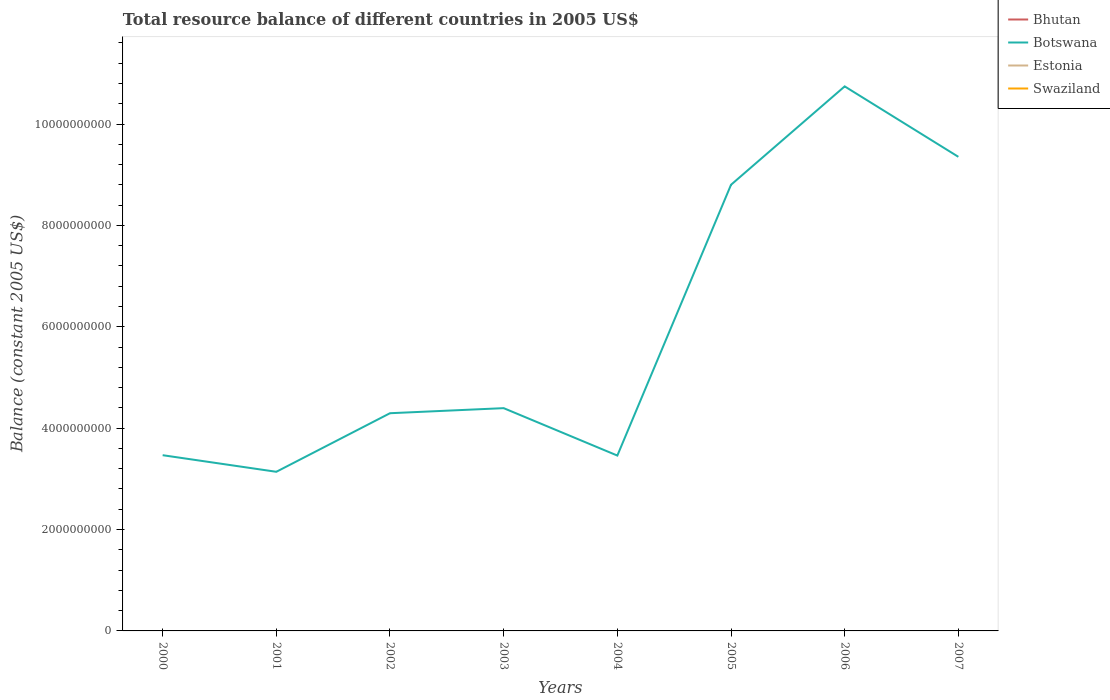Does the line corresponding to Swaziland intersect with the line corresponding to Bhutan?
Your answer should be compact. No. Is the number of lines equal to the number of legend labels?
Offer a terse response. No. What is the total total resource balance in Botswana in the graph?
Make the answer very short. -5.51e+08. What is the difference between the highest and the second highest total resource balance in Botswana?
Your response must be concise. 7.60e+09. What is the difference between the highest and the lowest total resource balance in Estonia?
Ensure brevity in your answer.  0. How many years are there in the graph?
Keep it short and to the point. 8. Are the values on the major ticks of Y-axis written in scientific E-notation?
Your response must be concise. No. Does the graph contain any zero values?
Give a very brief answer. Yes. Does the graph contain grids?
Offer a terse response. No. Where does the legend appear in the graph?
Ensure brevity in your answer.  Top right. How are the legend labels stacked?
Provide a succinct answer. Vertical. What is the title of the graph?
Make the answer very short. Total resource balance of different countries in 2005 US$. Does "Hong Kong" appear as one of the legend labels in the graph?
Keep it short and to the point. No. What is the label or title of the X-axis?
Keep it short and to the point. Years. What is the label or title of the Y-axis?
Offer a very short reply. Balance (constant 2005 US$). What is the Balance (constant 2005 US$) in Bhutan in 2000?
Your answer should be very brief. 0. What is the Balance (constant 2005 US$) in Botswana in 2000?
Your answer should be very brief. 3.47e+09. What is the Balance (constant 2005 US$) in Bhutan in 2001?
Offer a very short reply. 0. What is the Balance (constant 2005 US$) of Botswana in 2001?
Your answer should be compact. 3.14e+09. What is the Balance (constant 2005 US$) in Swaziland in 2001?
Give a very brief answer. 0. What is the Balance (constant 2005 US$) of Botswana in 2002?
Ensure brevity in your answer.  4.29e+09. What is the Balance (constant 2005 US$) in Estonia in 2002?
Your response must be concise. 0. What is the Balance (constant 2005 US$) of Swaziland in 2002?
Offer a very short reply. 0. What is the Balance (constant 2005 US$) in Botswana in 2003?
Give a very brief answer. 4.39e+09. What is the Balance (constant 2005 US$) of Estonia in 2003?
Your answer should be compact. 0. What is the Balance (constant 2005 US$) in Swaziland in 2003?
Provide a short and direct response. 0. What is the Balance (constant 2005 US$) in Bhutan in 2004?
Give a very brief answer. 0. What is the Balance (constant 2005 US$) of Botswana in 2004?
Offer a very short reply. 3.46e+09. What is the Balance (constant 2005 US$) in Swaziland in 2004?
Keep it short and to the point. 0. What is the Balance (constant 2005 US$) of Bhutan in 2005?
Your answer should be compact. 0. What is the Balance (constant 2005 US$) of Botswana in 2005?
Offer a terse response. 8.80e+09. What is the Balance (constant 2005 US$) in Estonia in 2005?
Provide a succinct answer. 0. What is the Balance (constant 2005 US$) of Swaziland in 2005?
Offer a terse response. 0. What is the Balance (constant 2005 US$) of Bhutan in 2006?
Keep it short and to the point. 0. What is the Balance (constant 2005 US$) of Botswana in 2006?
Offer a very short reply. 1.07e+1. What is the Balance (constant 2005 US$) in Swaziland in 2006?
Provide a succinct answer. 0. What is the Balance (constant 2005 US$) in Bhutan in 2007?
Your answer should be very brief. 0. What is the Balance (constant 2005 US$) in Botswana in 2007?
Your answer should be compact. 9.35e+09. What is the Balance (constant 2005 US$) of Estonia in 2007?
Provide a succinct answer. 0. What is the Balance (constant 2005 US$) of Swaziland in 2007?
Provide a short and direct response. 0. Across all years, what is the maximum Balance (constant 2005 US$) in Botswana?
Make the answer very short. 1.07e+1. Across all years, what is the minimum Balance (constant 2005 US$) in Botswana?
Your answer should be very brief. 3.14e+09. What is the total Balance (constant 2005 US$) of Bhutan in the graph?
Offer a very short reply. 0. What is the total Balance (constant 2005 US$) in Botswana in the graph?
Your answer should be compact. 4.77e+1. What is the difference between the Balance (constant 2005 US$) of Botswana in 2000 and that in 2001?
Your answer should be compact. 3.27e+08. What is the difference between the Balance (constant 2005 US$) in Botswana in 2000 and that in 2002?
Ensure brevity in your answer.  -8.28e+08. What is the difference between the Balance (constant 2005 US$) in Botswana in 2000 and that in 2003?
Provide a succinct answer. -9.28e+08. What is the difference between the Balance (constant 2005 US$) of Botswana in 2000 and that in 2004?
Ensure brevity in your answer.  7.10e+06. What is the difference between the Balance (constant 2005 US$) in Botswana in 2000 and that in 2005?
Your response must be concise. -5.33e+09. What is the difference between the Balance (constant 2005 US$) in Botswana in 2000 and that in 2006?
Offer a terse response. -7.28e+09. What is the difference between the Balance (constant 2005 US$) of Botswana in 2000 and that in 2007?
Your response must be concise. -5.89e+09. What is the difference between the Balance (constant 2005 US$) of Botswana in 2001 and that in 2002?
Make the answer very short. -1.16e+09. What is the difference between the Balance (constant 2005 US$) of Botswana in 2001 and that in 2003?
Give a very brief answer. -1.26e+09. What is the difference between the Balance (constant 2005 US$) in Botswana in 2001 and that in 2004?
Provide a succinct answer. -3.20e+08. What is the difference between the Balance (constant 2005 US$) of Botswana in 2001 and that in 2005?
Your response must be concise. -5.66e+09. What is the difference between the Balance (constant 2005 US$) in Botswana in 2001 and that in 2006?
Your answer should be very brief. -7.60e+09. What is the difference between the Balance (constant 2005 US$) of Botswana in 2001 and that in 2007?
Ensure brevity in your answer.  -6.21e+09. What is the difference between the Balance (constant 2005 US$) in Botswana in 2002 and that in 2003?
Ensure brevity in your answer.  -9.99e+07. What is the difference between the Balance (constant 2005 US$) in Botswana in 2002 and that in 2004?
Your response must be concise. 8.35e+08. What is the difference between the Balance (constant 2005 US$) in Botswana in 2002 and that in 2005?
Provide a short and direct response. -4.51e+09. What is the difference between the Balance (constant 2005 US$) of Botswana in 2002 and that in 2006?
Give a very brief answer. -6.45e+09. What is the difference between the Balance (constant 2005 US$) of Botswana in 2002 and that in 2007?
Your response must be concise. -5.06e+09. What is the difference between the Balance (constant 2005 US$) in Botswana in 2003 and that in 2004?
Keep it short and to the point. 9.35e+08. What is the difference between the Balance (constant 2005 US$) in Botswana in 2003 and that in 2005?
Give a very brief answer. -4.41e+09. What is the difference between the Balance (constant 2005 US$) in Botswana in 2003 and that in 2006?
Provide a short and direct response. -6.35e+09. What is the difference between the Balance (constant 2005 US$) in Botswana in 2003 and that in 2007?
Your answer should be very brief. -4.96e+09. What is the difference between the Balance (constant 2005 US$) of Botswana in 2004 and that in 2005?
Offer a terse response. -5.34e+09. What is the difference between the Balance (constant 2005 US$) in Botswana in 2004 and that in 2006?
Ensure brevity in your answer.  -7.28e+09. What is the difference between the Balance (constant 2005 US$) of Botswana in 2004 and that in 2007?
Provide a short and direct response. -5.89e+09. What is the difference between the Balance (constant 2005 US$) in Botswana in 2005 and that in 2006?
Provide a short and direct response. -1.94e+09. What is the difference between the Balance (constant 2005 US$) in Botswana in 2005 and that in 2007?
Offer a terse response. -5.51e+08. What is the difference between the Balance (constant 2005 US$) of Botswana in 2006 and that in 2007?
Make the answer very short. 1.39e+09. What is the average Balance (constant 2005 US$) in Bhutan per year?
Offer a terse response. 0. What is the average Balance (constant 2005 US$) in Botswana per year?
Your answer should be compact. 5.96e+09. What is the average Balance (constant 2005 US$) of Estonia per year?
Offer a terse response. 0. What is the average Balance (constant 2005 US$) in Swaziland per year?
Your answer should be compact. 0. What is the ratio of the Balance (constant 2005 US$) in Botswana in 2000 to that in 2001?
Offer a terse response. 1.1. What is the ratio of the Balance (constant 2005 US$) of Botswana in 2000 to that in 2002?
Your response must be concise. 0.81. What is the ratio of the Balance (constant 2005 US$) of Botswana in 2000 to that in 2003?
Your answer should be compact. 0.79. What is the ratio of the Balance (constant 2005 US$) in Botswana in 2000 to that in 2005?
Offer a very short reply. 0.39. What is the ratio of the Balance (constant 2005 US$) in Botswana in 2000 to that in 2006?
Your response must be concise. 0.32. What is the ratio of the Balance (constant 2005 US$) of Botswana in 2000 to that in 2007?
Your answer should be very brief. 0.37. What is the ratio of the Balance (constant 2005 US$) in Botswana in 2001 to that in 2002?
Your answer should be compact. 0.73. What is the ratio of the Balance (constant 2005 US$) in Botswana in 2001 to that in 2004?
Ensure brevity in your answer.  0.91. What is the ratio of the Balance (constant 2005 US$) of Botswana in 2001 to that in 2005?
Make the answer very short. 0.36. What is the ratio of the Balance (constant 2005 US$) in Botswana in 2001 to that in 2006?
Your answer should be compact. 0.29. What is the ratio of the Balance (constant 2005 US$) of Botswana in 2001 to that in 2007?
Your response must be concise. 0.34. What is the ratio of the Balance (constant 2005 US$) of Botswana in 2002 to that in 2003?
Offer a terse response. 0.98. What is the ratio of the Balance (constant 2005 US$) in Botswana in 2002 to that in 2004?
Offer a very short reply. 1.24. What is the ratio of the Balance (constant 2005 US$) in Botswana in 2002 to that in 2005?
Your answer should be very brief. 0.49. What is the ratio of the Balance (constant 2005 US$) in Botswana in 2002 to that in 2006?
Your response must be concise. 0.4. What is the ratio of the Balance (constant 2005 US$) of Botswana in 2002 to that in 2007?
Offer a terse response. 0.46. What is the ratio of the Balance (constant 2005 US$) of Botswana in 2003 to that in 2004?
Your answer should be compact. 1.27. What is the ratio of the Balance (constant 2005 US$) of Botswana in 2003 to that in 2005?
Offer a very short reply. 0.5. What is the ratio of the Balance (constant 2005 US$) in Botswana in 2003 to that in 2006?
Provide a short and direct response. 0.41. What is the ratio of the Balance (constant 2005 US$) in Botswana in 2003 to that in 2007?
Provide a succinct answer. 0.47. What is the ratio of the Balance (constant 2005 US$) of Botswana in 2004 to that in 2005?
Your response must be concise. 0.39. What is the ratio of the Balance (constant 2005 US$) in Botswana in 2004 to that in 2006?
Your response must be concise. 0.32. What is the ratio of the Balance (constant 2005 US$) in Botswana in 2004 to that in 2007?
Provide a succinct answer. 0.37. What is the ratio of the Balance (constant 2005 US$) of Botswana in 2005 to that in 2006?
Keep it short and to the point. 0.82. What is the ratio of the Balance (constant 2005 US$) of Botswana in 2005 to that in 2007?
Offer a terse response. 0.94. What is the ratio of the Balance (constant 2005 US$) in Botswana in 2006 to that in 2007?
Ensure brevity in your answer.  1.15. What is the difference between the highest and the second highest Balance (constant 2005 US$) in Botswana?
Give a very brief answer. 1.39e+09. What is the difference between the highest and the lowest Balance (constant 2005 US$) of Botswana?
Offer a very short reply. 7.60e+09. 